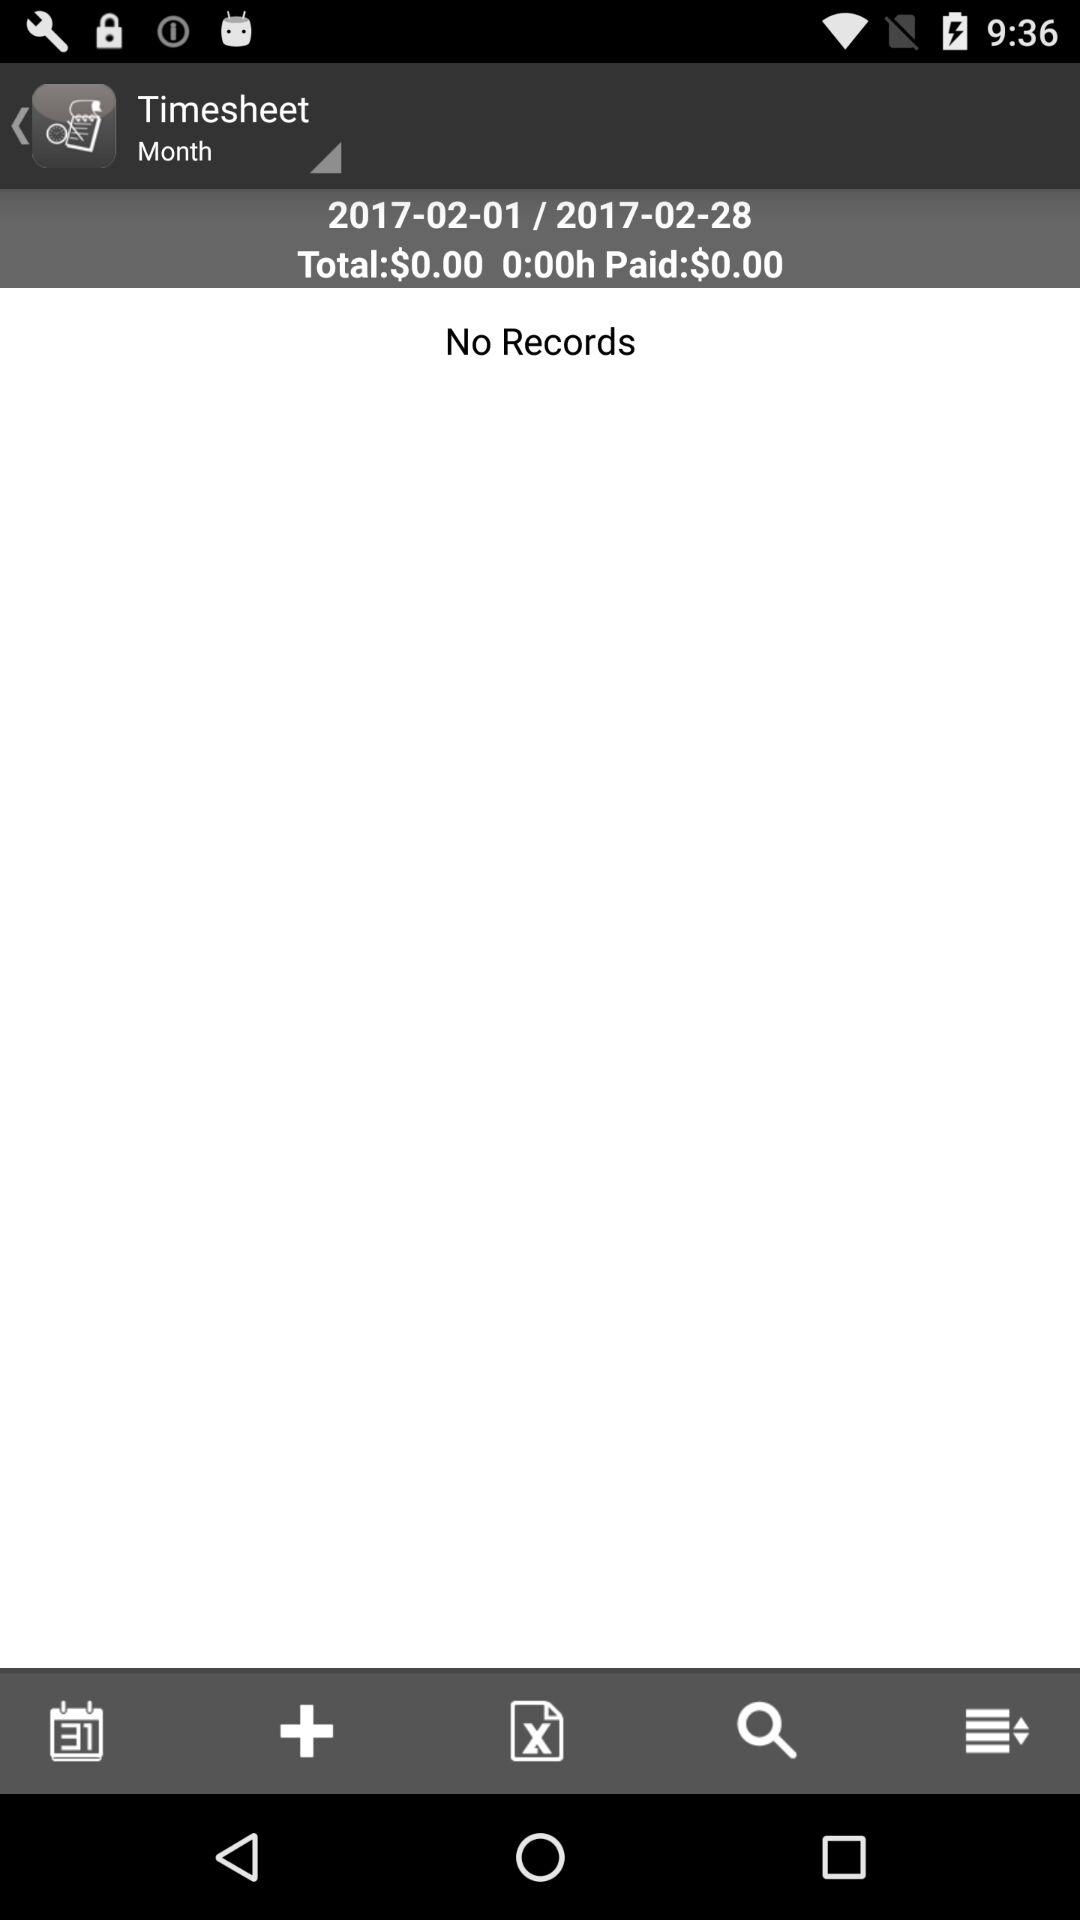How much is the total amount of money paid?
Answer the question using a single word or phrase. $0.00 